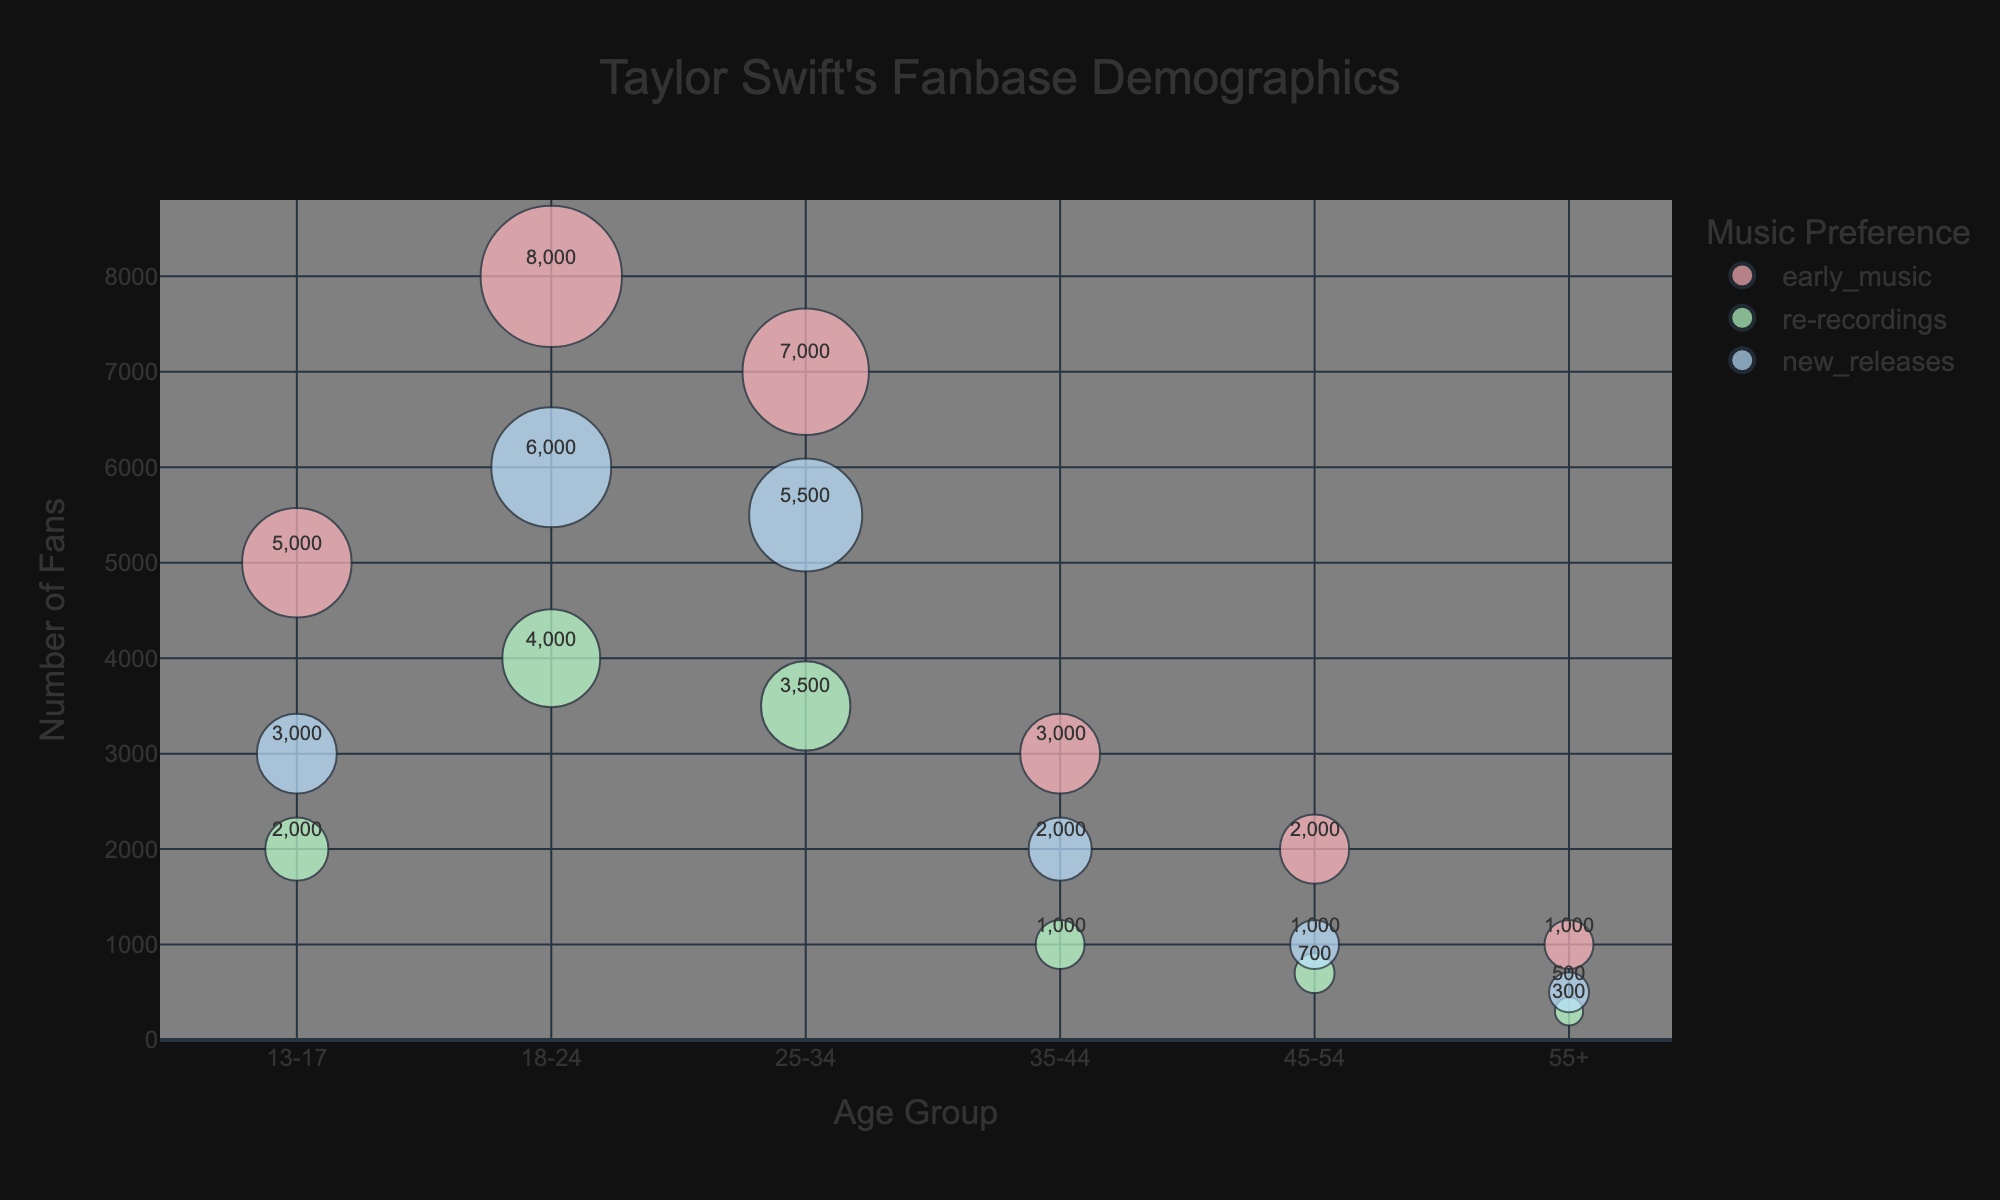Which age group has the highest number of fans for Taylor Swift's early music? The number of fans for early music is highest where the bubble size and transparency overlap indicate the most substantial following. Here, fans aged 18-24 most commonly prefer Taylor Swift's early music, evident from their large bubble size and placement higher on the y-axis.
Answer: 18-24 How many fans aged 25-34 prefer Taylor Swift's re-recordings? Locate the bubble corresponding to 25-34 age group and re-recordings category. The hover text or bubble annotation shows the number of fans.
Answer: 3,500 What is the size of the bubble representing fans aged 45-54 with a preference for early music? The bubble size corresponds to the fourth column in the dataset. By checking the annotations for the respective age group and preference, we see it’s 6 units.
Answer: 6 In which age group are re-recordings least popular? By looking for the smallest bubble in the re-recording category, it's clear that the 55+ age group shows the least preference.
Answer: 55+ How many more fans prefer early music over new releases in the 18-24 age group? Subtract the number of fans preferring new releases (6,000) from those preferring early music (8,000) in the 18-24 age group.
Answer: 2,000 Which music preference bubble is the largest among fans aged 13-17? Compare the sizes of the bubbles corresponding to early music, re-recordings, and new releases for the 13-17 age group. Early music has the largest bubble size.
Answer: Early music How does the number of fans preferring re-recordings in the 35-44 age group compare to the 45-54 age group? Compare the annotation values for re-recordings in the 35-44 and 45-54 age group. There are 1,000 fans in 35-44, compared to 700 in 45-54.
Answer: 300 more What is the total number of fans aged 55+? Sum the numbers of all bubble sizes within the 55+ age group: 1,000 + 300 + 500 = 1,800.
Answer: 1,800 What is the mean bubble size for the 18-24 age group across all music preferences? Add up the bubble sizes for each preference in this age group (25 + 12 + 18) and divide by 3. (25 + 12 + 18) / 3 = 55 / 3 ≈ 18.33.
Answer: 18.33 Which age group has the most uniform distribution of fan preferences across all three music categories? The age group with bubble sizes and colors appearing most evenly distributed across all preferences is 35-44, with relatively comparable bubble sizes for each music preference type.
Answer: 35-44 